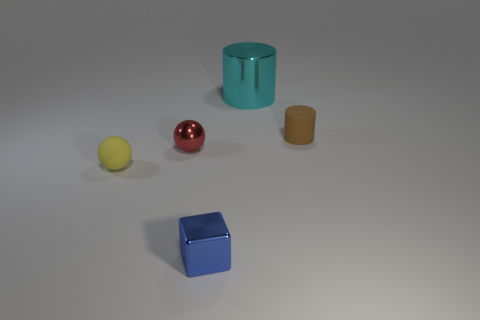Does the cylinder on the right side of the big metal cylinder have the same material as the thing behind the tiny brown cylinder? The cylinder on the right appears to be made of a material that differs in color and possibly texture from the object behind the small brown cylinder, suggesting they are not made of the same material. The cylinder on the right exhibits a teal hue and a metallic sheen, while the object behind the small brown cylinder seems to have a matte finish and a brownish-beige color, typical of objects made from clay or ceramic materials. 